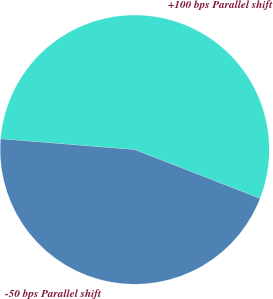Convert chart to OTSL. <chart><loc_0><loc_0><loc_500><loc_500><pie_chart><fcel>+100 bps Parallel shift<fcel>-50 bps Parallel shift<nl><fcel>54.64%<fcel>45.36%<nl></chart> 